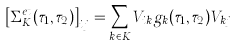Convert formula to latex. <formula><loc_0><loc_0><loc_500><loc_500>\left [ \Sigma ^ { e t } _ { K } ( \tau _ { 1 } , \tau _ { 2 } ) \right ] _ { i j } = \sum _ { k \in K } V _ { i k } g _ { k } ( \tau _ { 1 } , \tau _ { 2 } ) V _ { k j }</formula> 